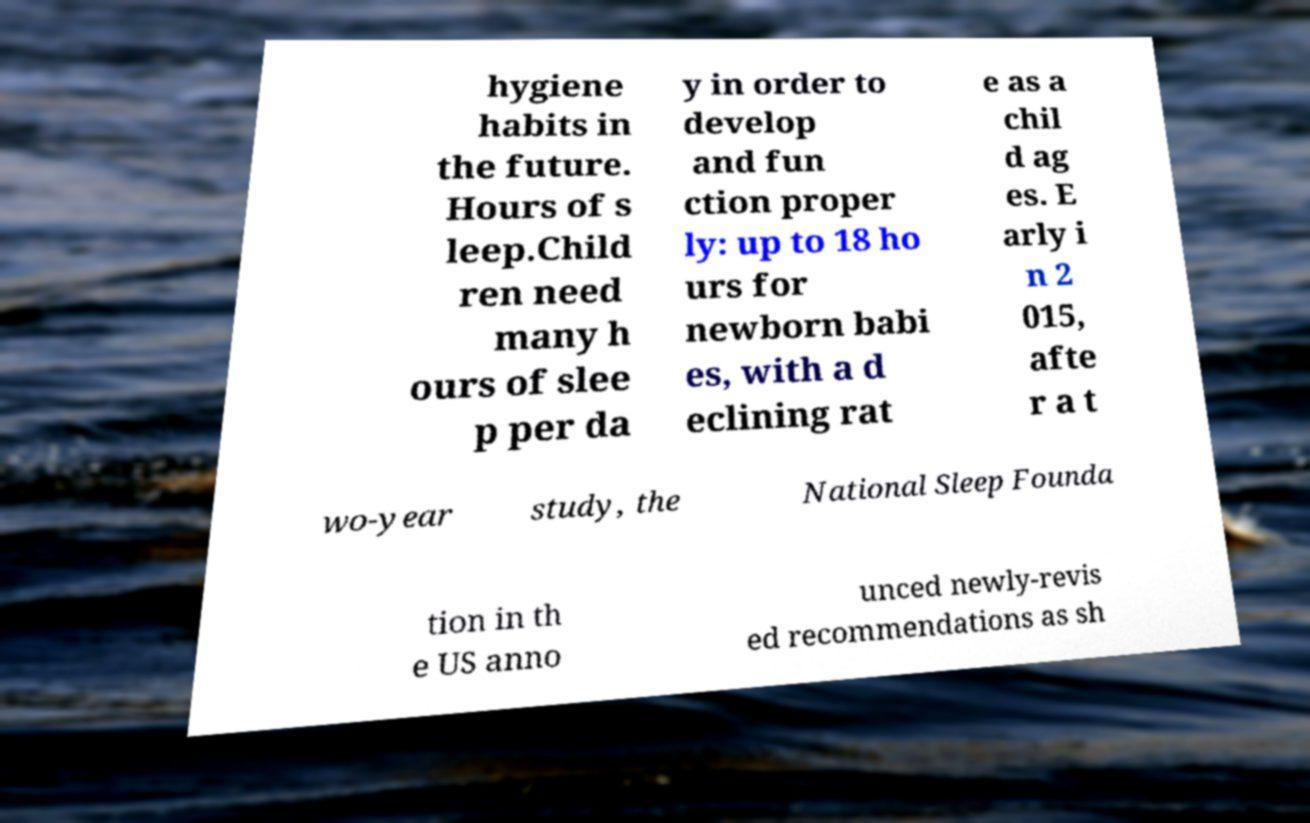Please identify and transcribe the text found in this image. hygiene habits in the future. Hours of s leep.Child ren need many h ours of slee p per da y in order to develop and fun ction proper ly: up to 18 ho urs for newborn babi es, with a d eclining rat e as a chil d ag es. E arly i n 2 015, afte r a t wo-year study, the National Sleep Founda tion in th e US anno unced newly-revis ed recommendations as sh 